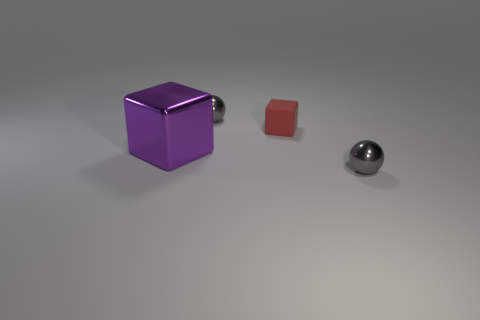Add 2 large purple blocks. How many objects exist? 6 Add 3 gray metal objects. How many gray metal objects are left? 5 Add 4 small red shiny objects. How many small red shiny objects exist? 4 Subtract 0 cyan spheres. How many objects are left? 4 Subtract all small red rubber cubes. Subtract all small red rubber objects. How many objects are left? 2 